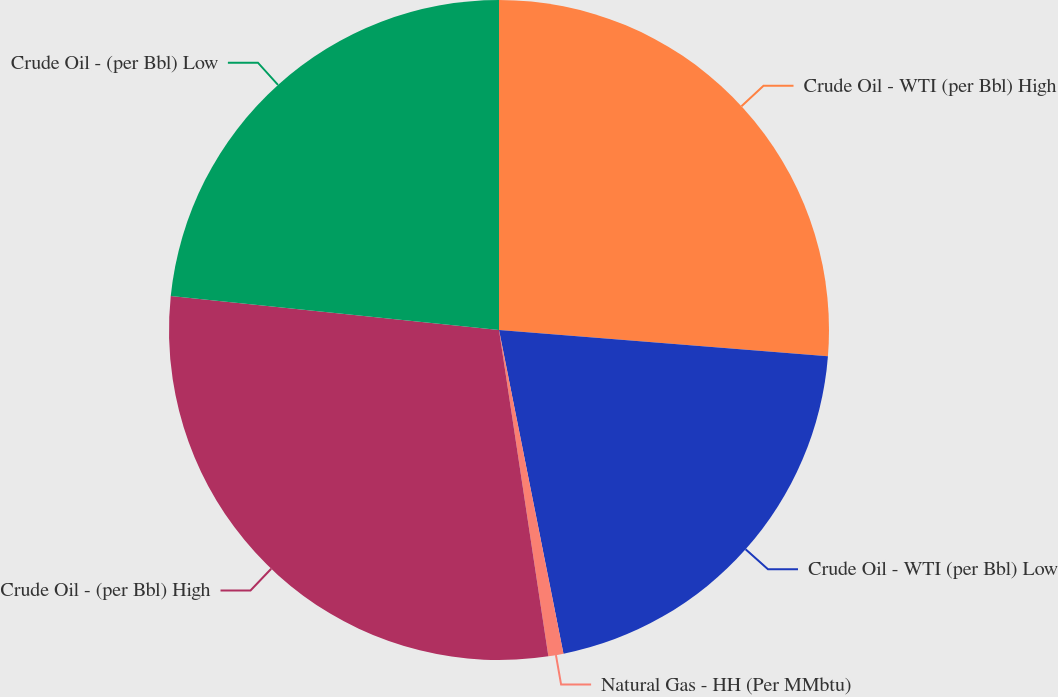Convert chart to OTSL. <chart><loc_0><loc_0><loc_500><loc_500><pie_chart><fcel>Crude Oil - WTI (per Bbl) High<fcel>Crude Oil - WTI (per Bbl) Low<fcel>Natural Gas - HH (Per MMbtu)<fcel>Crude Oil - (per Bbl) High<fcel>Crude Oil - (per Bbl) Low<nl><fcel>26.27%<fcel>20.6%<fcel>0.74%<fcel>29.03%<fcel>23.36%<nl></chart> 